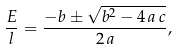<formula> <loc_0><loc_0><loc_500><loc_500>\frac { E } { l } = \frac { - b \pm \sqrt { b ^ { 2 } - 4 \, a \, c } } { 2 \, a } ,</formula> 